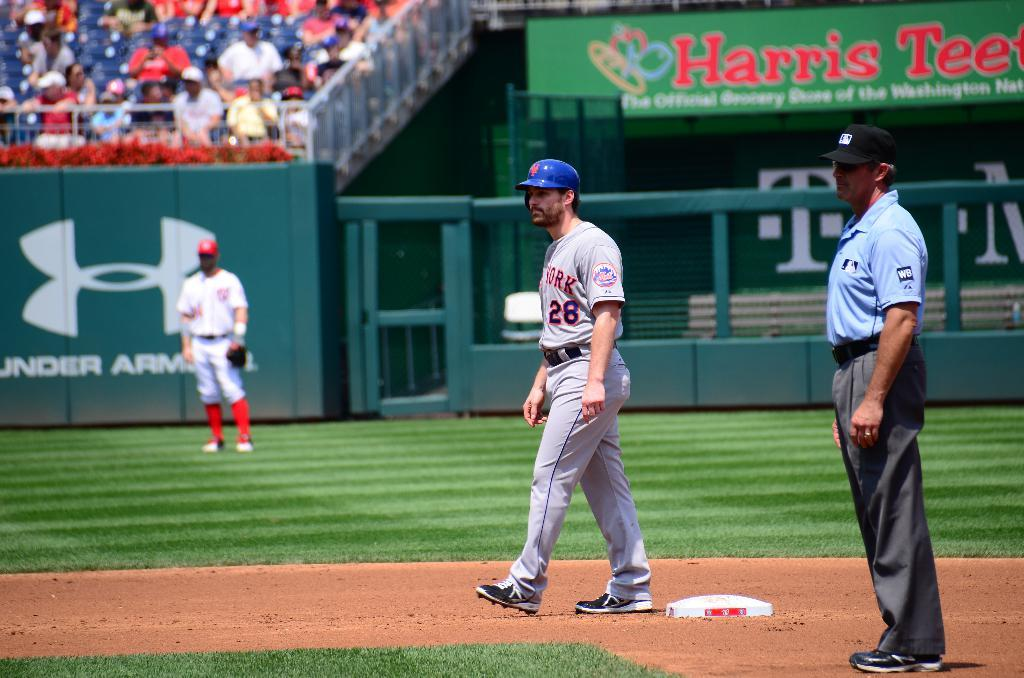Provide a one-sentence caption for the provided image. A baseball player wears a uniform with New York on the chest. 